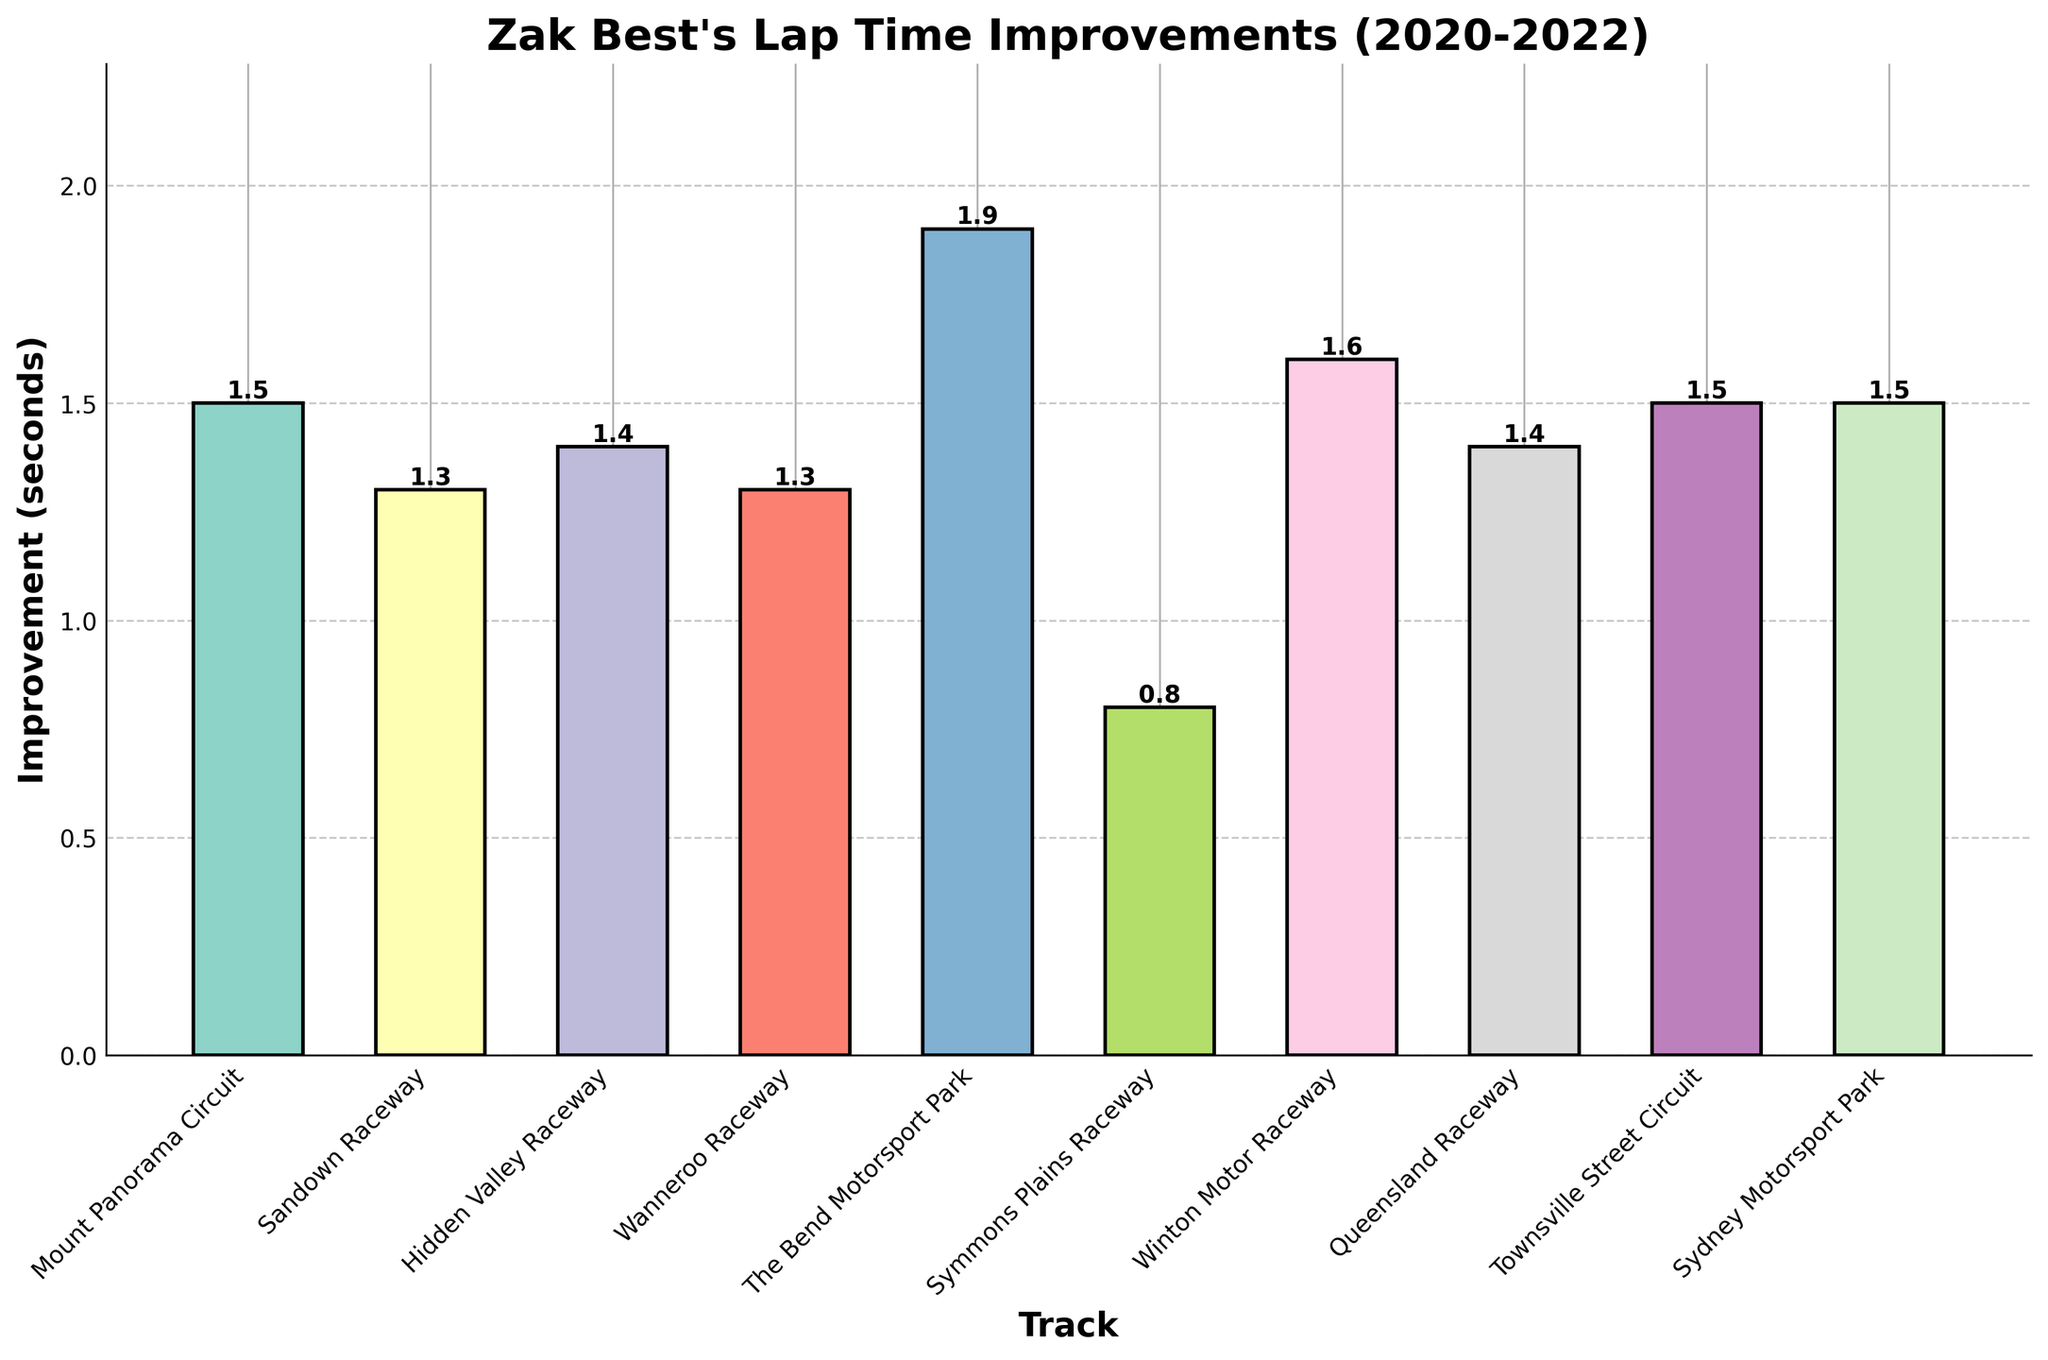Which track showed the greatest improvement in lap time? Look at the height of bars on the chart. The tallest bar represents the greatest improvement. The Bend Motorsport Park has the highest bar, indicating the greatest improvement.
Answer: The Bend Motorsport Park Which track showed the least improvement in lap time? Identify the shortest bar on the chart. The shortest bar corresponds to Symmons Plains Raceway, which indicates the least improvement.
Answer: Symmons Plains Raceway How many tracks showed an improvement equal to or greater than 1.5 seconds? Count the number of bars with heights of 1.5 seconds or higher. There are four bars (Mount Panorama Circuit, Winton Motor Raceway, Townsville Street Circuit, and Sydney Motorsport Park) that satisfy this condition.
Answer: 4 What is the average lap time improvement across all tracks? Sum up all the improvement values and divide by the number of tracks. The total improvement is 13.2 seconds, and there are 10 tracks, giving an average improvement of 1.32 seconds.
Answer: 1.32 seconds Are there more tracks with improvements above the average or below the average? First, identify the average improvement (1.32 seconds). Count the number of tracks with improvements above and below this value. Six tracks show improvements greater than 1.32 seconds, and four tracks show improvements less than 1.32 seconds.
Answer: Above the average Which two tracks have the smallest difference in their lap time improvements? Find the difference in improvements for each pair of tracks and identify the smallest difference. The difference between Sandown Raceway and Wanneroo Raceway is 0.0 seconds, which is the smallest.
Answer: Sandown Raceway and Wanneroo Raceway What is the combined improvement in lap times for Hidden Valley Raceway and Queensland Raceway? Add the improvements of Hidden Valley Raceway (1.4 seconds) and Queensland Raceway (1.4 seconds). The combined improvement is 2.8 seconds.
Answer: 2.8 seconds Which tracks have exactly the same amount of improvement? Look for bars of equal height on the chart. Hidden Valley Raceway and Queensland Raceway both have improvements of 1.4 seconds.
Answer: Hidden Valley Raceway and Queensland Raceway Which improvement is greater, the combined improvement of Mount Panorama Circuit and Winton Motor Raceway or that of Townsville Street Circuit and Sydney Motorsport Park? First, sum the improvements for each pair: (Mount Panorama Circuit + Winton Motor Raceway) = 3.1 seconds and (Townsville Street Circuit + Sydney Motorsport Park) = 3.0 seconds. Then compare the sums; 3.1 seconds is greater.
Answer: Mount Panorama Circuit and Winton Motor Raceway Which track's improvement is closest to the median improvement value? Arrange all improvement values in ascending order and find the median. The median improvement is 1.4 seconds. The tracks with improvements of 1.4 seconds are Hidden Valley Raceway and Queensland Raceway.
Answer: Hidden Valley Raceway and Queensland Raceway 